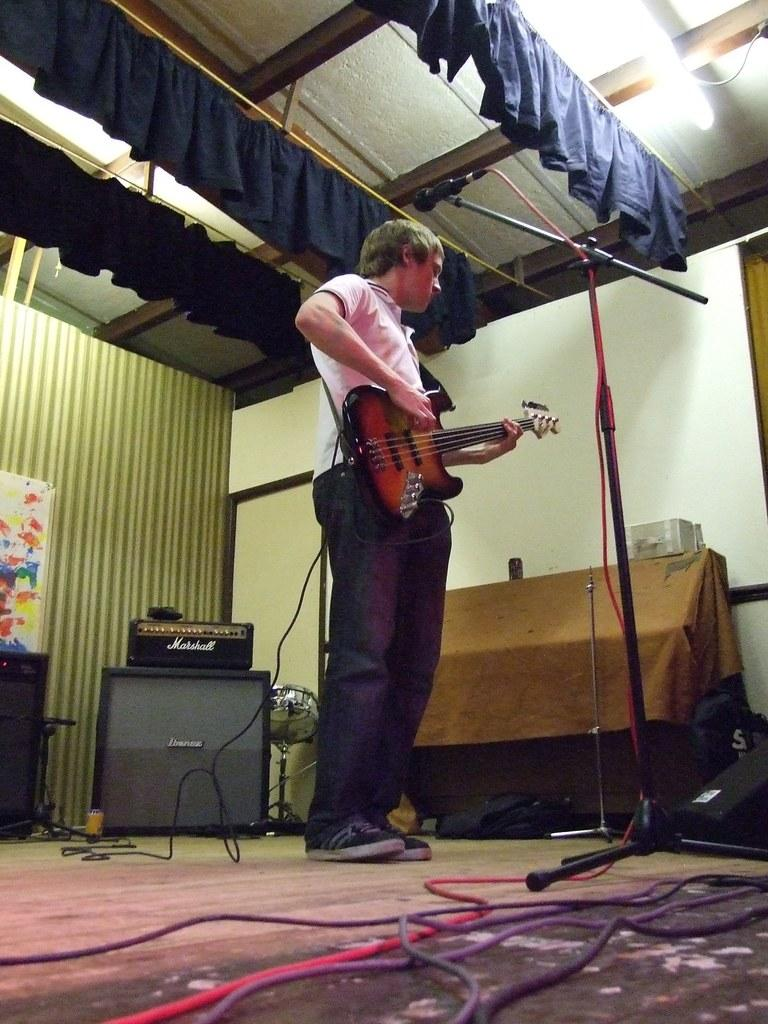What is the man in the image doing? The man is playing a guitar. What object is in front of the man? There is a microphone in front of the man. Can you see any bushes or a stream in the image? There is no mention of bushes or a stream in the provided facts, so we cannot determine their presence in the image. 